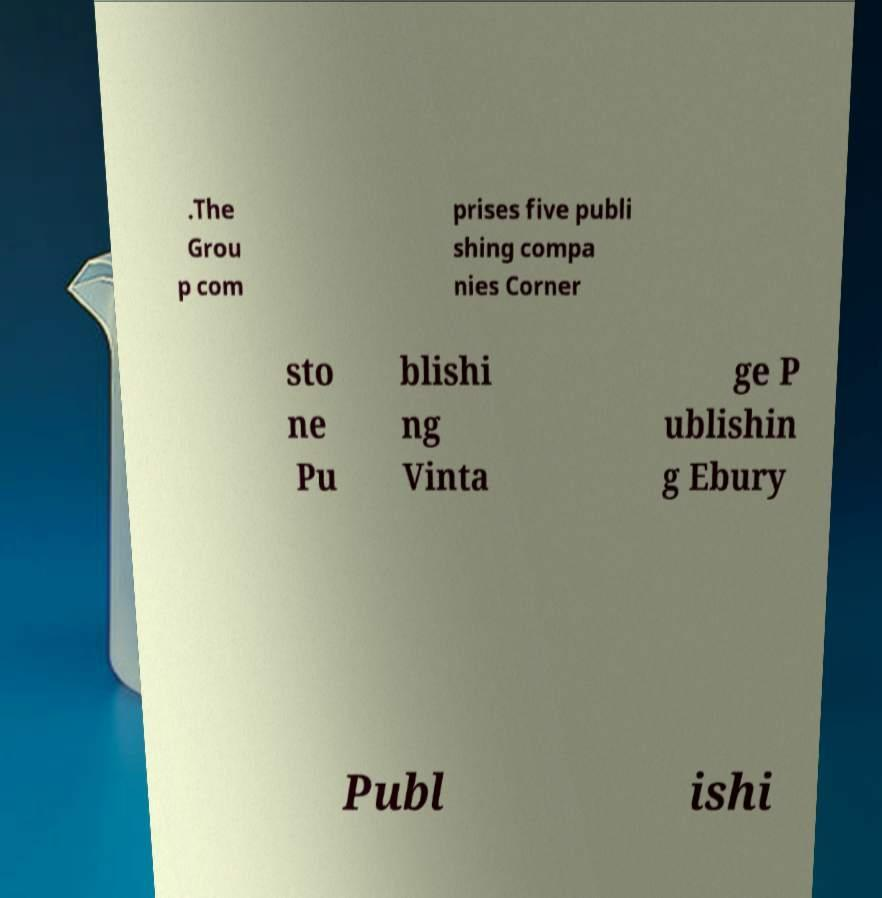For documentation purposes, I need the text within this image transcribed. Could you provide that? .The Grou p com prises five publi shing compa nies Corner sto ne Pu blishi ng Vinta ge P ublishin g Ebury Publ ishi 